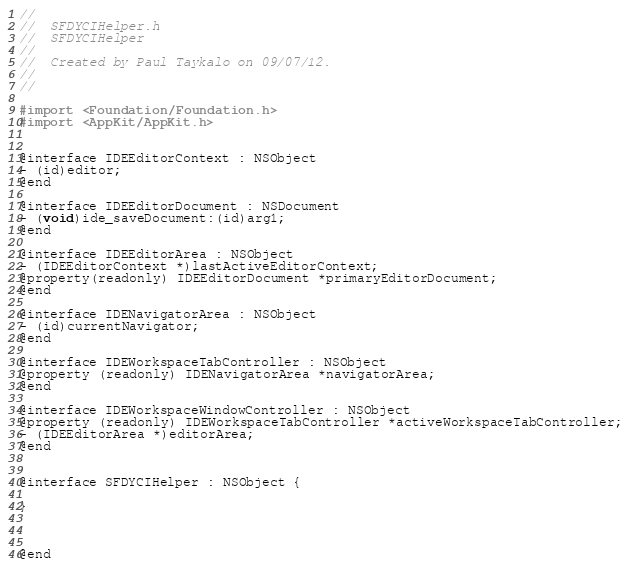Convert code to text. <code><loc_0><loc_0><loc_500><loc_500><_C_>//
//  SFDYCIHelper.h
//  SFDYCIHelper
//
//  Created by Paul Taykalo on 09/07/12.
//
//

#import <Foundation/Foundation.h>
#import <AppKit/AppKit.h>


@interface IDEEditorContext : NSObject
- (id)editor;
@end

@interface IDEEditorDocument : NSDocument
- (void)ide_saveDocument:(id)arg1;
@end

@interface IDEEditorArea : NSObject
- (IDEEditorContext *)lastActiveEditorContext;
@property(readonly) IDEEditorDocument *primaryEditorDocument;
@end

@interface IDENavigatorArea : NSObject
- (id)currentNavigator;
@end

@interface IDEWorkspaceTabController : NSObject
@property (readonly) IDENavigatorArea *navigatorArea;
@end

@interface IDEWorkspaceWindowController : NSObject
@property (readonly) IDEWorkspaceTabController *activeWorkspaceTabController;
- (IDEEditorArea *)editorArea;
@end


@interface SFDYCIHelper : NSObject {
	
}



@end
</code> 